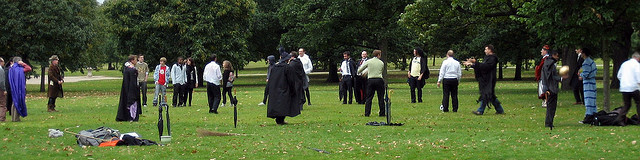<image>What color are the umbrellas? I cannot determine the color of the umbrellas as there are no umbrellas in the image. What type of tree are they standing in front of? I am not sure what type of tree they are standing in front of. It could be an oak, maple, or elm. What color are the umbrellas? It is unanswerable what color are the umbrellas. There are none shown in the image. What type of tree are they standing in front of? I don't know what type of tree they are standing in front of. It can be oak, maple or elm. 